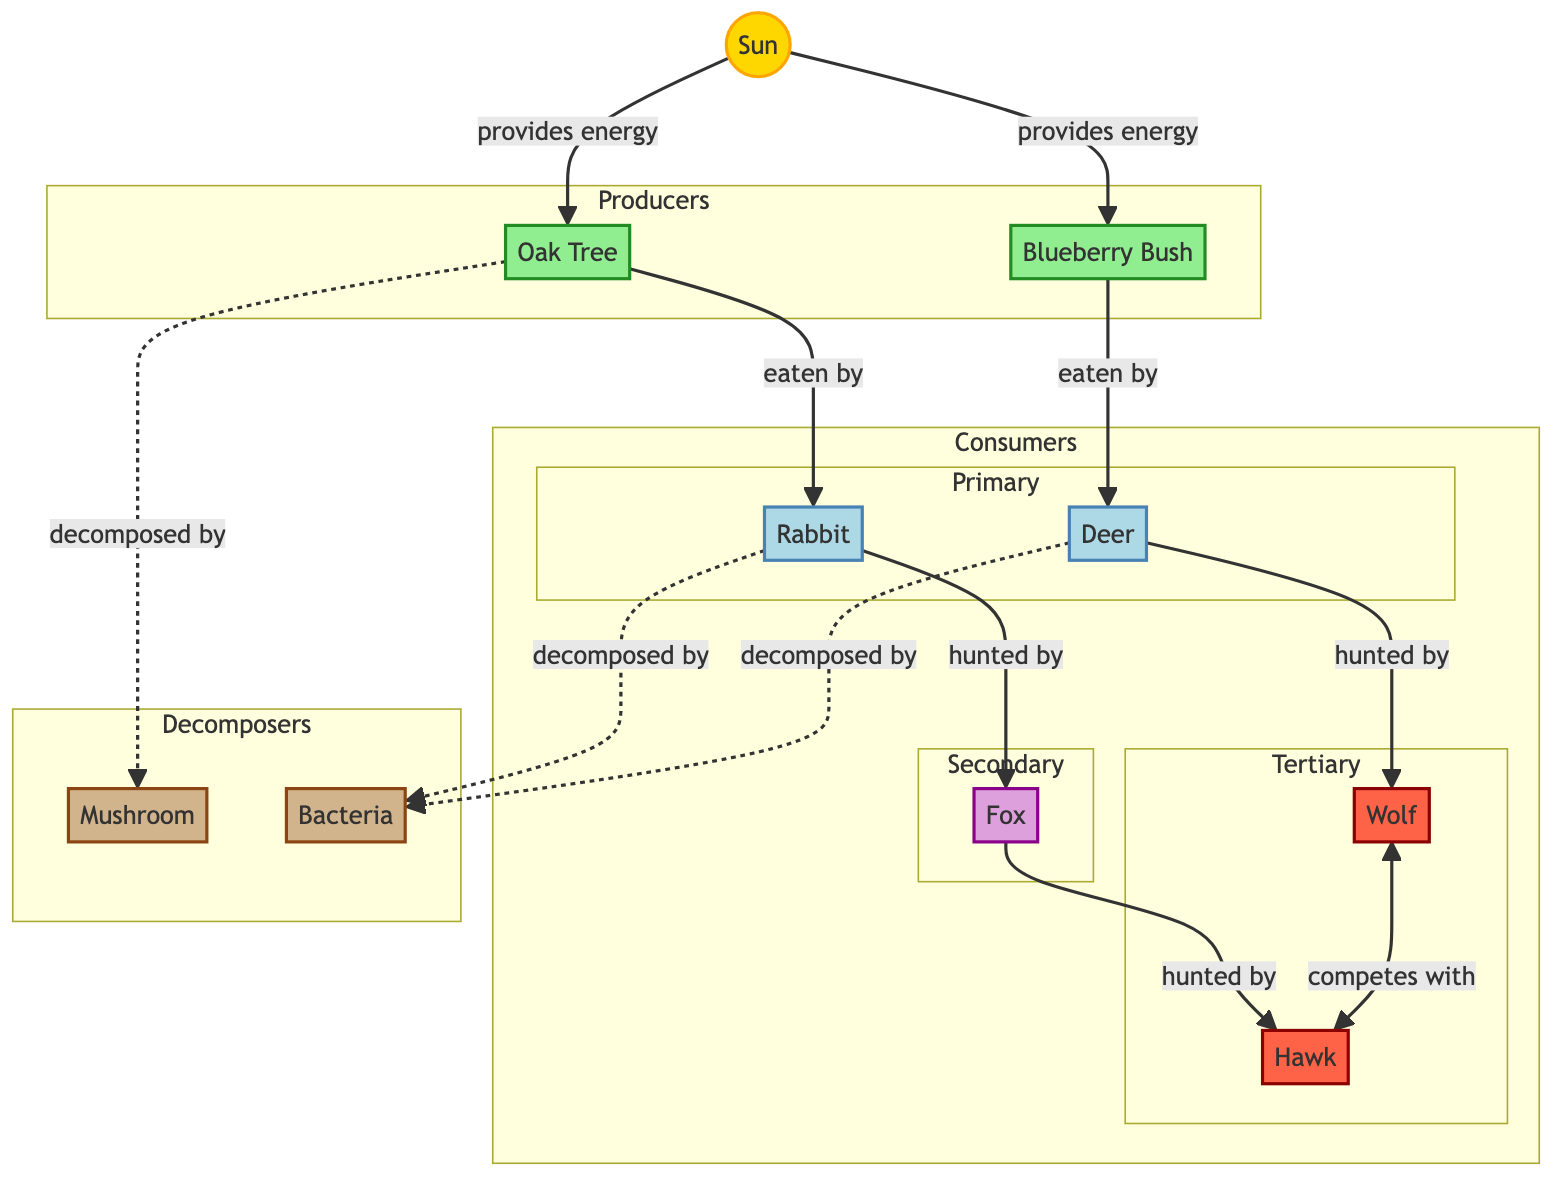What are the producers in this ecosystem? The diagram shows two nodes identified as producers: the Oak Tree and the Blueberry Bush. These nodes are connected to the Sun, which provides energy to them.
Answer: Oak Tree and Blueberry Bush Which animal is hunted by the fox? According to the connections in the diagram, the rabbit is directly linked to being hunted by the fox. The arrow indicates a predatory relationship.
Answer: Rabbit How many decomposers are present in this ecosystem? The diagram lists two decomposer nodes: the Mushroom and Bacteria. Counting these nodes gives a total of two decomposers in the ecosystem.
Answer: 2 What type of relationship exists between the wolf and the hawk? The diagram clearly shows a competitive relationship between the wolf and the hawk, indicated by the bi-directional arrow. Both species compete for similar resources.
Answer: Competes Which organism is at the top of the food chain? By analyzing the predator-prey relationships, the wolf and hawk are the tertiary consumers, but since there is no animal above them in the hierarchy depicted, we identify the wolf as part of the apex predators in this ecosystem.
Answer: Wolf How is the oak tree decomposed? The diagram specifies that the Oak Tree is decomposed by the Mushroom, indicated by the dashed line connecting them. This signifies the role of the mushroom as a decomposer in breaking down the oak tree.
Answer: Mushroom 